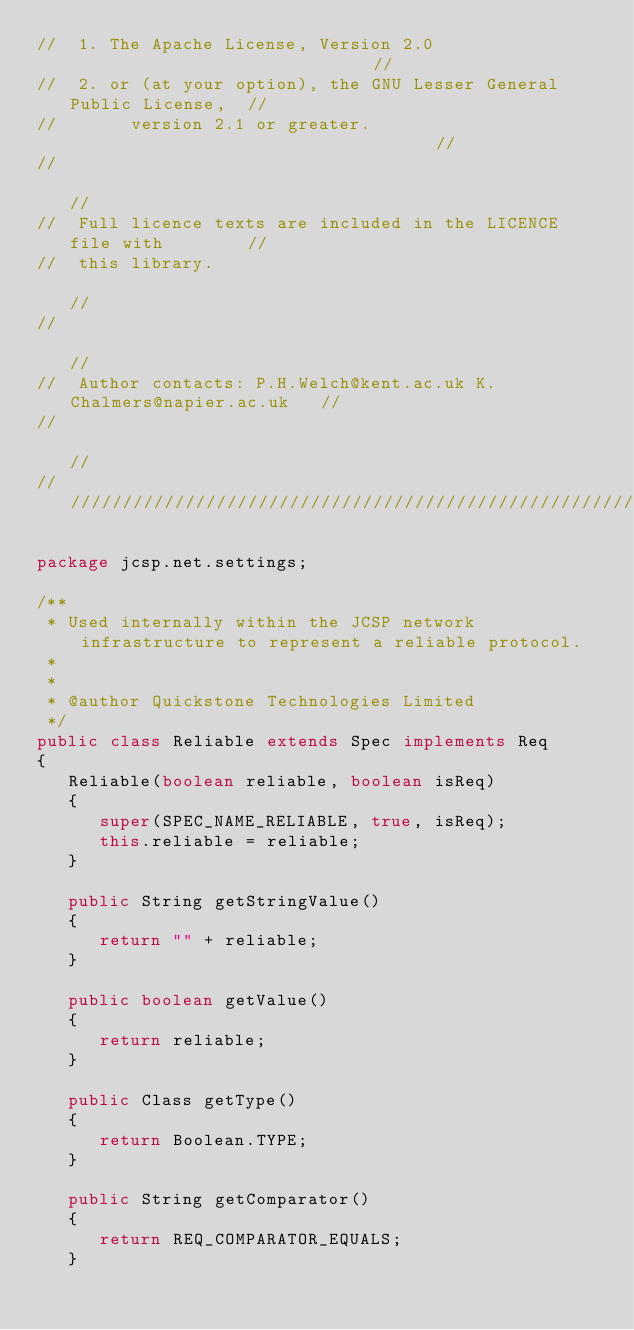Convert code to text. <code><loc_0><loc_0><loc_500><loc_500><_Java_>//  1. The Apache License, Version 2.0                              //
//  2. or (at your option), the GNU Lesser General Public License,  //
//       version 2.1 or greater.                                    //
//                                                                  //
//  Full licence texts are included in the LICENCE file with        //
//  this library.                                                   //
//                                                                  //
//  Author contacts: P.H.Welch@kent.ac.uk K.Chalmers@napier.ac.uk   //
//                                                                  //
//////////////////////////////////////////////////////////////////////

package jcsp.net.settings;

/**
 * Used internally within the JCSP network infrastructure to represent a reliable protocol.
 *
 *
 * @author Quickstone Technologies Limited
 */
public class Reliable extends Spec implements Req
{
   Reliable(boolean reliable, boolean isReq)
   {
      super(SPEC_NAME_RELIABLE, true, isReq);
      this.reliable = reliable;
   }
   
   public String getStringValue()
   {
      return "" + reliable;
   }
   
   public boolean getValue()
   {
      return reliable;
   }
   
   public Class getType()
   {
      return Boolean.TYPE;
   }
   
   public String getComparator()
   {
      return REQ_COMPARATOR_EQUALS;
   }
   </code> 